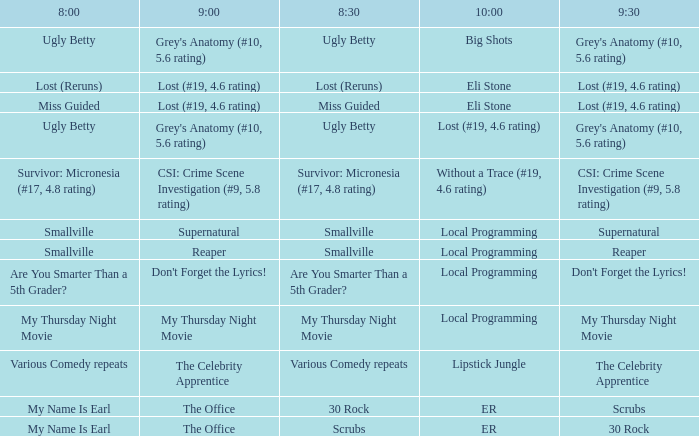What is at 10:00 when at 9:00 it is reaper? Local Programming. 